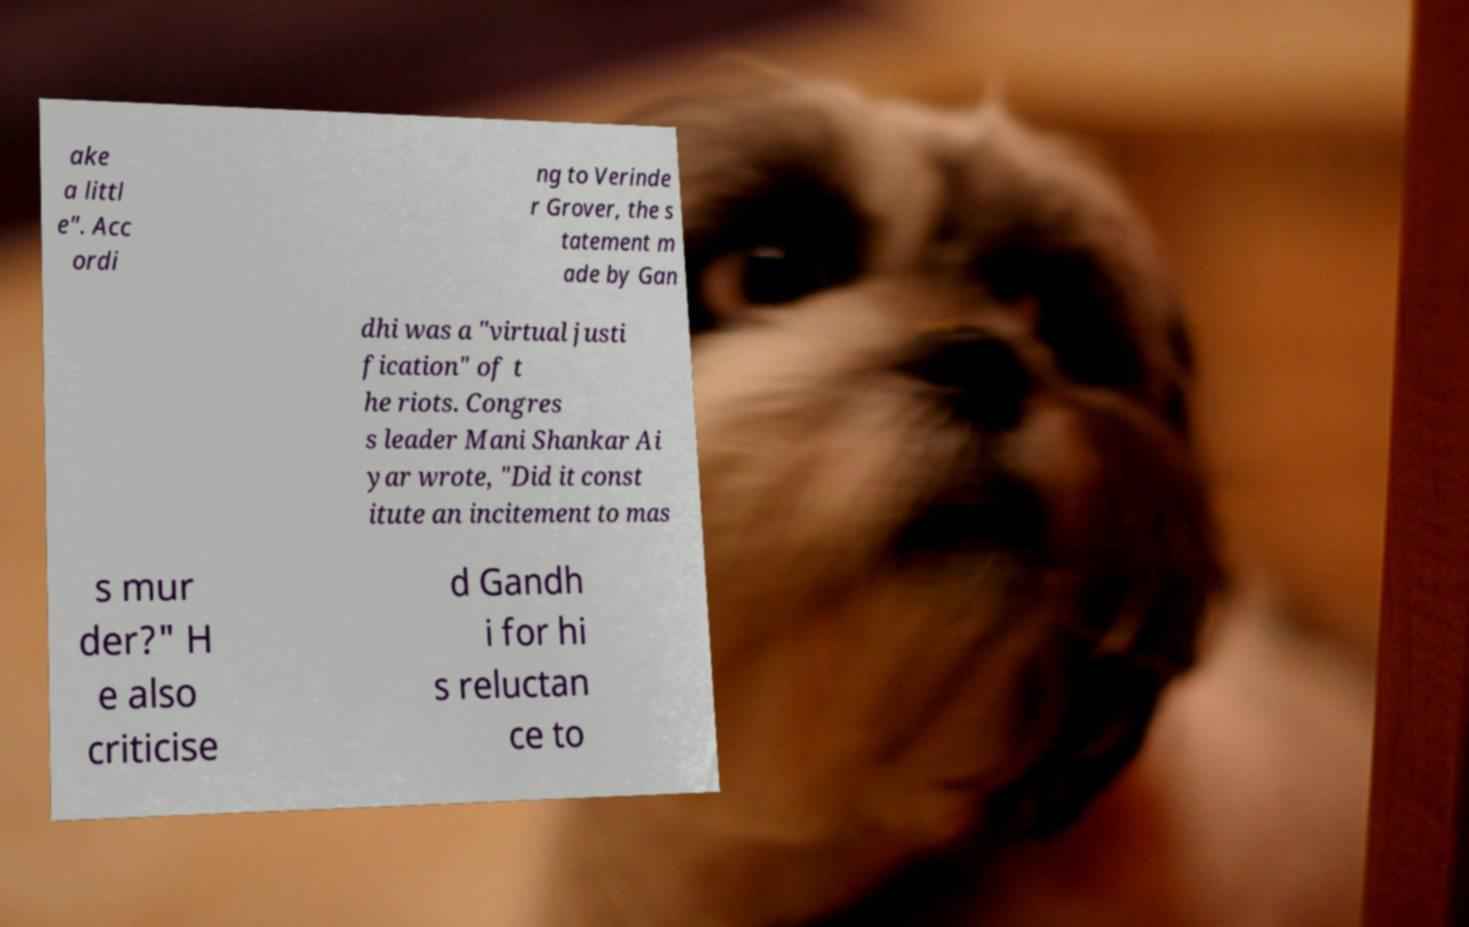There's text embedded in this image that I need extracted. Can you transcribe it verbatim? ake a littl e". Acc ordi ng to Verinde r Grover, the s tatement m ade by Gan dhi was a "virtual justi fication" of t he riots. Congres s leader Mani Shankar Ai yar wrote, "Did it const itute an incitement to mas s mur der?" H e also criticise d Gandh i for hi s reluctan ce to 